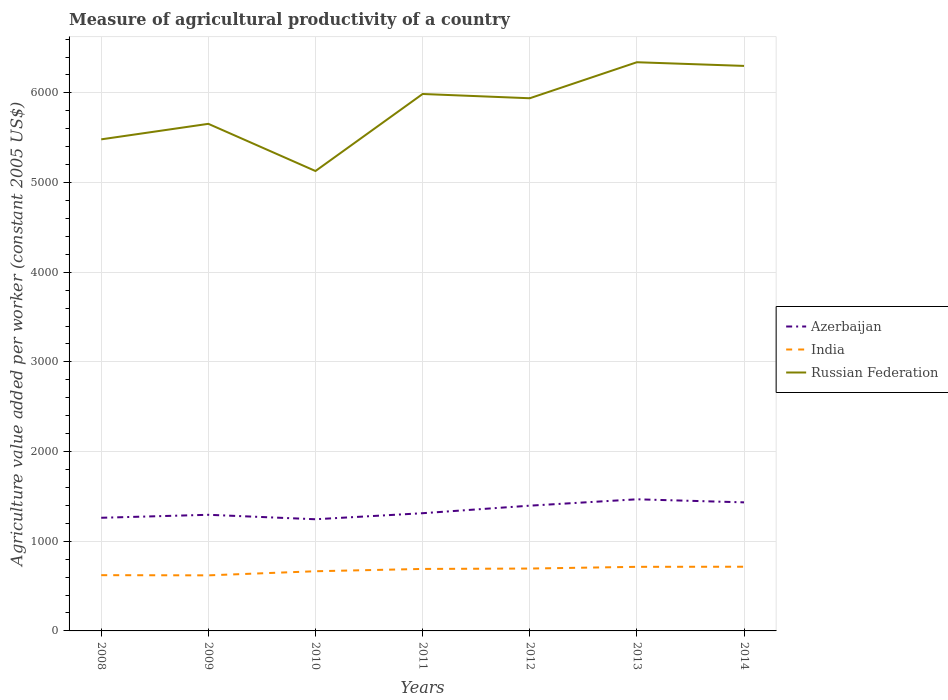Across all years, what is the maximum measure of agricultural productivity in Azerbaijan?
Make the answer very short. 1245.42. What is the total measure of agricultural productivity in Azerbaijan in the graph?
Your response must be concise. -50.89. What is the difference between the highest and the second highest measure of agricultural productivity in Azerbaijan?
Offer a very short reply. 222.61. What is the difference between the highest and the lowest measure of agricultural productivity in Russian Federation?
Ensure brevity in your answer.  4. Is the measure of agricultural productivity in Russian Federation strictly greater than the measure of agricultural productivity in Azerbaijan over the years?
Keep it short and to the point. No. How many lines are there?
Offer a very short reply. 3. How many years are there in the graph?
Give a very brief answer. 7. Are the values on the major ticks of Y-axis written in scientific E-notation?
Provide a short and direct response. No. Does the graph contain grids?
Your answer should be compact. Yes. Where does the legend appear in the graph?
Keep it short and to the point. Center right. How many legend labels are there?
Provide a succinct answer. 3. What is the title of the graph?
Your response must be concise. Measure of agricultural productivity of a country. Does "World" appear as one of the legend labels in the graph?
Provide a succinct answer. No. What is the label or title of the X-axis?
Offer a terse response. Years. What is the label or title of the Y-axis?
Provide a succinct answer. Agriculture value added per worker (constant 2005 US$). What is the Agriculture value added per worker (constant 2005 US$) in Azerbaijan in 2008?
Provide a short and direct response. 1261.92. What is the Agriculture value added per worker (constant 2005 US$) in India in 2008?
Give a very brief answer. 621.78. What is the Agriculture value added per worker (constant 2005 US$) of Russian Federation in 2008?
Offer a very short reply. 5482.32. What is the Agriculture value added per worker (constant 2005 US$) of Azerbaijan in 2009?
Provide a succinct answer. 1295.18. What is the Agriculture value added per worker (constant 2005 US$) in India in 2009?
Your response must be concise. 619.73. What is the Agriculture value added per worker (constant 2005 US$) of Russian Federation in 2009?
Make the answer very short. 5655.3. What is the Agriculture value added per worker (constant 2005 US$) in Azerbaijan in 2010?
Make the answer very short. 1245.42. What is the Agriculture value added per worker (constant 2005 US$) of India in 2010?
Offer a terse response. 665.55. What is the Agriculture value added per worker (constant 2005 US$) of Russian Federation in 2010?
Your answer should be compact. 5129.11. What is the Agriculture value added per worker (constant 2005 US$) of Azerbaijan in 2011?
Provide a succinct answer. 1312.81. What is the Agriculture value added per worker (constant 2005 US$) of India in 2011?
Provide a succinct answer. 691.34. What is the Agriculture value added per worker (constant 2005 US$) of Russian Federation in 2011?
Ensure brevity in your answer.  5988.32. What is the Agriculture value added per worker (constant 2005 US$) in Azerbaijan in 2012?
Your answer should be very brief. 1396.89. What is the Agriculture value added per worker (constant 2005 US$) of India in 2012?
Make the answer very short. 695.62. What is the Agriculture value added per worker (constant 2005 US$) in Russian Federation in 2012?
Ensure brevity in your answer.  5940.66. What is the Agriculture value added per worker (constant 2005 US$) in Azerbaijan in 2013?
Offer a very short reply. 1468.03. What is the Agriculture value added per worker (constant 2005 US$) in India in 2013?
Keep it short and to the point. 714.85. What is the Agriculture value added per worker (constant 2005 US$) in Russian Federation in 2013?
Ensure brevity in your answer.  6342.4. What is the Agriculture value added per worker (constant 2005 US$) in Azerbaijan in 2014?
Make the answer very short. 1433.81. What is the Agriculture value added per worker (constant 2005 US$) of India in 2014?
Your response must be concise. 715.89. What is the Agriculture value added per worker (constant 2005 US$) of Russian Federation in 2014?
Provide a short and direct response. 6301.37. Across all years, what is the maximum Agriculture value added per worker (constant 2005 US$) of Azerbaijan?
Make the answer very short. 1468.03. Across all years, what is the maximum Agriculture value added per worker (constant 2005 US$) of India?
Provide a succinct answer. 715.89. Across all years, what is the maximum Agriculture value added per worker (constant 2005 US$) in Russian Federation?
Offer a terse response. 6342.4. Across all years, what is the minimum Agriculture value added per worker (constant 2005 US$) in Azerbaijan?
Give a very brief answer. 1245.42. Across all years, what is the minimum Agriculture value added per worker (constant 2005 US$) in India?
Keep it short and to the point. 619.73. Across all years, what is the minimum Agriculture value added per worker (constant 2005 US$) in Russian Federation?
Ensure brevity in your answer.  5129.11. What is the total Agriculture value added per worker (constant 2005 US$) in Azerbaijan in the graph?
Offer a terse response. 9414.06. What is the total Agriculture value added per worker (constant 2005 US$) in India in the graph?
Offer a very short reply. 4724.77. What is the total Agriculture value added per worker (constant 2005 US$) in Russian Federation in the graph?
Ensure brevity in your answer.  4.08e+04. What is the difference between the Agriculture value added per worker (constant 2005 US$) in Azerbaijan in 2008 and that in 2009?
Provide a short and direct response. -33.26. What is the difference between the Agriculture value added per worker (constant 2005 US$) in India in 2008 and that in 2009?
Provide a succinct answer. 2.05. What is the difference between the Agriculture value added per worker (constant 2005 US$) in Russian Federation in 2008 and that in 2009?
Provide a short and direct response. -172.98. What is the difference between the Agriculture value added per worker (constant 2005 US$) of Azerbaijan in 2008 and that in 2010?
Your answer should be very brief. 16.5. What is the difference between the Agriculture value added per worker (constant 2005 US$) of India in 2008 and that in 2010?
Your answer should be very brief. -43.77. What is the difference between the Agriculture value added per worker (constant 2005 US$) in Russian Federation in 2008 and that in 2010?
Make the answer very short. 353.21. What is the difference between the Agriculture value added per worker (constant 2005 US$) in Azerbaijan in 2008 and that in 2011?
Ensure brevity in your answer.  -50.89. What is the difference between the Agriculture value added per worker (constant 2005 US$) in India in 2008 and that in 2011?
Give a very brief answer. -69.57. What is the difference between the Agriculture value added per worker (constant 2005 US$) in Russian Federation in 2008 and that in 2011?
Ensure brevity in your answer.  -506. What is the difference between the Agriculture value added per worker (constant 2005 US$) in Azerbaijan in 2008 and that in 2012?
Offer a very short reply. -134.97. What is the difference between the Agriculture value added per worker (constant 2005 US$) in India in 2008 and that in 2012?
Your answer should be very brief. -73.85. What is the difference between the Agriculture value added per worker (constant 2005 US$) in Russian Federation in 2008 and that in 2012?
Ensure brevity in your answer.  -458.34. What is the difference between the Agriculture value added per worker (constant 2005 US$) in Azerbaijan in 2008 and that in 2013?
Keep it short and to the point. -206.11. What is the difference between the Agriculture value added per worker (constant 2005 US$) of India in 2008 and that in 2013?
Ensure brevity in your answer.  -93.08. What is the difference between the Agriculture value added per worker (constant 2005 US$) of Russian Federation in 2008 and that in 2013?
Ensure brevity in your answer.  -860.08. What is the difference between the Agriculture value added per worker (constant 2005 US$) in Azerbaijan in 2008 and that in 2014?
Your answer should be compact. -171.89. What is the difference between the Agriculture value added per worker (constant 2005 US$) in India in 2008 and that in 2014?
Make the answer very short. -94.12. What is the difference between the Agriculture value added per worker (constant 2005 US$) of Russian Federation in 2008 and that in 2014?
Offer a very short reply. -819.05. What is the difference between the Agriculture value added per worker (constant 2005 US$) in Azerbaijan in 2009 and that in 2010?
Your response must be concise. 49.77. What is the difference between the Agriculture value added per worker (constant 2005 US$) of India in 2009 and that in 2010?
Keep it short and to the point. -45.82. What is the difference between the Agriculture value added per worker (constant 2005 US$) of Russian Federation in 2009 and that in 2010?
Provide a succinct answer. 526.19. What is the difference between the Agriculture value added per worker (constant 2005 US$) in Azerbaijan in 2009 and that in 2011?
Keep it short and to the point. -17.63. What is the difference between the Agriculture value added per worker (constant 2005 US$) of India in 2009 and that in 2011?
Keep it short and to the point. -71.62. What is the difference between the Agriculture value added per worker (constant 2005 US$) in Russian Federation in 2009 and that in 2011?
Keep it short and to the point. -333.01. What is the difference between the Agriculture value added per worker (constant 2005 US$) in Azerbaijan in 2009 and that in 2012?
Provide a succinct answer. -101.71. What is the difference between the Agriculture value added per worker (constant 2005 US$) of India in 2009 and that in 2012?
Provide a succinct answer. -75.9. What is the difference between the Agriculture value added per worker (constant 2005 US$) in Russian Federation in 2009 and that in 2012?
Keep it short and to the point. -285.35. What is the difference between the Agriculture value added per worker (constant 2005 US$) of Azerbaijan in 2009 and that in 2013?
Offer a terse response. -172.85. What is the difference between the Agriculture value added per worker (constant 2005 US$) in India in 2009 and that in 2013?
Keep it short and to the point. -95.12. What is the difference between the Agriculture value added per worker (constant 2005 US$) in Russian Federation in 2009 and that in 2013?
Offer a very short reply. -687.09. What is the difference between the Agriculture value added per worker (constant 2005 US$) of Azerbaijan in 2009 and that in 2014?
Ensure brevity in your answer.  -138.63. What is the difference between the Agriculture value added per worker (constant 2005 US$) in India in 2009 and that in 2014?
Your answer should be very brief. -96.16. What is the difference between the Agriculture value added per worker (constant 2005 US$) in Russian Federation in 2009 and that in 2014?
Your answer should be very brief. -646.07. What is the difference between the Agriculture value added per worker (constant 2005 US$) in Azerbaijan in 2010 and that in 2011?
Make the answer very short. -67.39. What is the difference between the Agriculture value added per worker (constant 2005 US$) in India in 2010 and that in 2011?
Make the answer very short. -25.79. What is the difference between the Agriculture value added per worker (constant 2005 US$) in Russian Federation in 2010 and that in 2011?
Your answer should be compact. -859.21. What is the difference between the Agriculture value added per worker (constant 2005 US$) in Azerbaijan in 2010 and that in 2012?
Your answer should be very brief. -151.47. What is the difference between the Agriculture value added per worker (constant 2005 US$) of India in 2010 and that in 2012?
Your answer should be compact. -30.07. What is the difference between the Agriculture value added per worker (constant 2005 US$) in Russian Federation in 2010 and that in 2012?
Your response must be concise. -811.55. What is the difference between the Agriculture value added per worker (constant 2005 US$) in Azerbaijan in 2010 and that in 2013?
Provide a short and direct response. -222.61. What is the difference between the Agriculture value added per worker (constant 2005 US$) in India in 2010 and that in 2013?
Provide a succinct answer. -49.3. What is the difference between the Agriculture value added per worker (constant 2005 US$) in Russian Federation in 2010 and that in 2013?
Provide a short and direct response. -1213.29. What is the difference between the Agriculture value added per worker (constant 2005 US$) in Azerbaijan in 2010 and that in 2014?
Your response must be concise. -188.39. What is the difference between the Agriculture value added per worker (constant 2005 US$) in India in 2010 and that in 2014?
Provide a short and direct response. -50.34. What is the difference between the Agriculture value added per worker (constant 2005 US$) of Russian Federation in 2010 and that in 2014?
Offer a very short reply. -1172.26. What is the difference between the Agriculture value added per worker (constant 2005 US$) in Azerbaijan in 2011 and that in 2012?
Make the answer very short. -84.08. What is the difference between the Agriculture value added per worker (constant 2005 US$) in India in 2011 and that in 2012?
Offer a terse response. -4.28. What is the difference between the Agriculture value added per worker (constant 2005 US$) of Russian Federation in 2011 and that in 2012?
Your answer should be compact. 47.66. What is the difference between the Agriculture value added per worker (constant 2005 US$) in Azerbaijan in 2011 and that in 2013?
Offer a terse response. -155.22. What is the difference between the Agriculture value added per worker (constant 2005 US$) of India in 2011 and that in 2013?
Your answer should be compact. -23.51. What is the difference between the Agriculture value added per worker (constant 2005 US$) in Russian Federation in 2011 and that in 2013?
Offer a terse response. -354.08. What is the difference between the Agriculture value added per worker (constant 2005 US$) in Azerbaijan in 2011 and that in 2014?
Your answer should be compact. -121. What is the difference between the Agriculture value added per worker (constant 2005 US$) in India in 2011 and that in 2014?
Provide a succinct answer. -24.55. What is the difference between the Agriculture value added per worker (constant 2005 US$) of Russian Federation in 2011 and that in 2014?
Provide a succinct answer. -313.05. What is the difference between the Agriculture value added per worker (constant 2005 US$) of Azerbaijan in 2012 and that in 2013?
Provide a short and direct response. -71.14. What is the difference between the Agriculture value added per worker (constant 2005 US$) in India in 2012 and that in 2013?
Your answer should be very brief. -19.23. What is the difference between the Agriculture value added per worker (constant 2005 US$) in Russian Federation in 2012 and that in 2013?
Give a very brief answer. -401.74. What is the difference between the Agriculture value added per worker (constant 2005 US$) of Azerbaijan in 2012 and that in 2014?
Offer a terse response. -36.92. What is the difference between the Agriculture value added per worker (constant 2005 US$) of India in 2012 and that in 2014?
Offer a terse response. -20.27. What is the difference between the Agriculture value added per worker (constant 2005 US$) of Russian Federation in 2012 and that in 2014?
Give a very brief answer. -360.71. What is the difference between the Agriculture value added per worker (constant 2005 US$) of Azerbaijan in 2013 and that in 2014?
Ensure brevity in your answer.  34.22. What is the difference between the Agriculture value added per worker (constant 2005 US$) of India in 2013 and that in 2014?
Offer a terse response. -1.04. What is the difference between the Agriculture value added per worker (constant 2005 US$) in Russian Federation in 2013 and that in 2014?
Provide a succinct answer. 41.03. What is the difference between the Agriculture value added per worker (constant 2005 US$) in Azerbaijan in 2008 and the Agriculture value added per worker (constant 2005 US$) in India in 2009?
Provide a short and direct response. 642.19. What is the difference between the Agriculture value added per worker (constant 2005 US$) of Azerbaijan in 2008 and the Agriculture value added per worker (constant 2005 US$) of Russian Federation in 2009?
Your response must be concise. -4393.38. What is the difference between the Agriculture value added per worker (constant 2005 US$) in India in 2008 and the Agriculture value added per worker (constant 2005 US$) in Russian Federation in 2009?
Your answer should be very brief. -5033.53. What is the difference between the Agriculture value added per worker (constant 2005 US$) in Azerbaijan in 2008 and the Agriculture value added per worker (constant 2005 US$) in India in 2010?
Give a very brief answer. 596.37. What is the difference between the Agriculture value added per worker (constant 2005 US$) of Azerbaijan in 2008 and the Agriculture value added per worker (constant 2005 US$) of Russian Federation in 2010?
Offer a terse response. -3867.19. What is the difference between the Agriculture value added per worker (constant 2005 US$) in India in 2008 and the Agriculture value added per worker (constant 2005 US$) in Russian Federation in 2010?
Keep it short and to the point. -4507.33. What is the difference between the Agriculture value added per worker (constant 2005 US$) in Azerbaijan in 2008 and the Agriculture value added per worker (constant 2005 US$) in India in 2011?
Your response must be concise. 570.58. What is the difference between the Agriculture value added per worker (constant 2005 US$) of Azerbaijan in 2008 and the Agriculture value added per worker (constant 2005 US$) of Russian Federation in 2011?
Keep it short and to the point. -4726.4. What is the difference between the Agriculture value added per worker (constant 2005 US$) of India in 2008 and the Agriculture value added per worker (constant 2005 US$) of Russian Federation in 2011?
Your response must be concise. -5366.54. What is the difference between the Agriculture value added per worker (constant 2005 US$) in Azerbaijan in 2008 and the Agriculture value added per worker (constant 2005 US$) in India in 2012?
Provide a succinct answer. 566.3. What is the difference between the Agriculture value added per worker (constant 2005 US$) of Azerbaijan in 2008 and the Agriculture value added per worker (constant 2005 US$) of Russian Federation in 2012?
Give a very brief answer. -4678.74. What is the difference between the Agriculture value added per worker (constant 2005 US$) of India in 2008 and the Agriculture value added per worker (constant 2005 US$) of Russian Federation in 2012?
Offer a terse response. -5318.88. What is the difference between the Agriculture value added per worker (constant 2005 US$) in Azerbaijan in 2008 and the Agriculture value added per worker (constant 2005 US$) in India in 2013?
Your answer should be compact. 547.07. What is the difference between the Agriculture value added per worker (constant 2005 US$) in Azerbaijan in 2008 and the Agriculture value added per worker (constant 2005 US$) in Russian Federation in 2013?
Provide a succinct answer. -5080.48. What is the difference between the Agriculture value added per worker (constant 2005 US$) of India in 2008 and the Agriculture value added per worker (constant 2005 US$) of Russian Federation in 2013?
Your response must be concise. -5720.62. What is the difference between the Agriculture value added per worker (constant 2005 US$) in Azerbaijan in 2008 and the Agriculture value added per worker (constant 2005 US$) in India in 2014?
Ensure brevity in your answer.  546.03. What is the difference between the Agriculture value added per worker (constant 2005 US$) of Azerbaijan in 2008 and the Agriculture value added per worker (constant 2005 US$) of Russian Federation in 2014?
Your answer should be very brief. -5039.45. What is the difference between the Agriculture value added per worker (constant 2005 US$) in India in 2008 and the Agriculture value added per worker (constant 2005 US$) in Russian Federation in 2014?
Ensure brevity in your answer.  -5679.59. What is the difference between the Agriculture value added per worker (constant 2005 US$) of Azerbaijan in 2009 and the Agriculture value added per worker (constant 2005 US$) of India in 2010?
Offer a very short reply. 629.63. What is the difference between the Agriculture value added per worker (constant 2005 US$) in Azerbaijan in 2009 and the Agriculture value added per worker (constant 2005 US$) in Russian Federation in 2010?
Offer a terse response. -3833.93. What is the difference between the Agriculture value added per worker (constant 2005 US$) in India in 2009 and the Agriculture value added per worker (constant 2005 US$) in Russian Federation in 2010?
Provide a short and direct response. -4509.38. What is the difference between the Agriculture value added per worker (constant 2005 US$) in Azerbaijan in 2009 and the Agriculture value added per worker (constant 2005 US$) in India in 2011?
Offer a very short reply. 603.84. What is the difference between the Agriculture value added per worker (constant 2005 US$) in Azerbaijan in 2009 and the Agriculture value added per worker (constant 2005 US$) in Russian Federation in 2011?
Provide a succinct answer. -4693.13. What is the difference between the Agriculture value added per worker (constant 2005 US$) in India in 2009 and the Agriculture value added per worker (constant 2005 US$) in Russian Federation in 2011?
Your response must be concise. -5368.59. What is the difference between the Agriculture value added per worker (constant 2005 US$) in Azerbaijan in 2009 and the Agriculture value added per worker (constant 2005 US$) in India in 2012?
Keep it short and to the point. 599.56. What is the difference between the Agriculture value added per worker (constant 2005 US$) of Azerbaijan in 2009 and the Agriculture value added per worker (constant 2005 US$) of Russian Federation in 2012?
Give a very brief answer. -4645.48. What is the difference between the Agriculture value added per worker (constant 2005 US$) in India in 2009 and the Agriculture value added per worker (constant 2005 US$) in Russian Federation in 2012?
Your response must be concise. -5320.93. What is the difference between the Agriculture value added per worker (constant 2005 US$) in Azerbaijan in 2009 and the Agriculture value added per worker (constant 2005 US$) in India in 2013?
Offer a terse response. 580.33. What is the difference between the Agriculture value added per worker (constant 2005 US$) of Azerbaijan in 2009 and the Agriculture value added per worker (constant 2005 US$) of Russian Federation in 2013?
Your answer should be very brief. -5047.21. What is the difference between the Agriculture value added per worker (constant 2005 US$) in India in 2009 and the Agriculture value added per worker (constant 2005 US$) in Russian Federation in 2013?
Your answer should be very brief. -5722.67. What is the difference between the Agriculture value added per worker (constant 2005 US$) in Azerbaijan in 2009 and the Agriculture value added per worker (constant 2005 US$) in India in 2014?
Keep it short and to the point. 579.29. What is the difference between the Agriculture value added per worker (constant 2005 US$) of Azerbaijan in 2009 and the Agriculture value added per worker (constant 2005 US$) of Russian Federation in 2014?
Provide a succinct answer. -5006.19. What is the difference between the Agriculture value added per worker (constant 2005 US$) in India in 2009 and the Agriculture value added per worker (constant 2005 US$) in Russian Federation in 2014?
Provide a succinct answer. -5681.64. What is the difference between the Agriculture value added per worker (constant 2005 US$) of Azerbaijan in 2010 and the Agriculture value added per worker (constant 2005 US$) of India in 2011?
Your answer should be very brief. 554.07. What is the difference between the Agriculture value added per worker (constant 2005 US$) in Azerbaijan in 2010 and the Agriculture value added per worker (constant 2005 US$) in Russian Federation in 2011?
Give a very brief answer. -4742.9. What is the difference between the Agriculture value added per worker (constant 2005 US$) of India in 2010 and the Agriculture value added per worker (constant 2005 US$) of Russian Federation in 2011?
Your response must be concise. -5322.77. What is the difference between the Agriculture value added per worker (constant 2005 US$) in Azerbaijan in 2010 and the Agriculture value added per worker (constant 2005 US$) in India in 2012?
Keep it short and to the point. 549.79. What is the difference between the Agriculture value added per worker (constant 2005 US$) of Azerbaijan in 2010 and the Agriculture value added per worker (constant 2005 US$) of Russian Federation in 2012?
Your answer should be compact. -4695.24. What is the difference between the Agriculture value added per worker (constant 2005 US$) in India in 2010 and the Agriculture value added per worker (constant 2005 US$) in Russian Federation in 2012?
Offer a very short reply. -5275.11. What is the difference between the Agriculture value added per worker (constant 2005 US$) of Azerbaijan in 2010 and the Agriculture value added per worker (constant 2005 US$) of India in 2013?
Make the answer very short. 530.56. What is the difference between the Agriculture value added per worker (constant 2005 US$) of Azerbaijan in 2010 and the Agriculture value added per worker (constant 2005 US$) of Russian Federation in 2013?
Provide a succinct answer. -5096.98. What is the difference between the Agriculture value added per worker (constant 2005 US$) of India in 2010 and the Agriculture value added per worker (constant 2005 US$) of Russian Federation in 2013?
Make the answer very short. -5676.85. What is the difference between the Agriculture value added per worker (constant 2005 US$) in Azerbaijan in 2010 and the Agriculture value added per worker (constant 2005 US$) in India in 2014?
Offer a very short reply. 529.52. What is the difference between the Agriculture value added per worker (constant 2005 US$) in Azerbaijan in 2010 and the Agriculture value added per worker (constant 2005 US$) in Russian Federation in 2014?
Make the answer very short. -5055.95. What is the difference between the Agriculture value added per worker (constant 2005 US$) of India in 2010 and the Agriculture value added per worker (constant 2005 US$) of Russian Federation in 2014?
Provide a succinct answer. -5635.82. What is the difference between the Agriculture value added per worker (constant 2005 US$) of Azerbaijan in 2011 and the Agriculture value added per worker (constant 2005 US$) of India in 2012?
Give a very brief answer. 617.19. What is the difference between the Agriculture value added per worker (constant 2005 US$) of Azerbaijan in 2011 and the Agriculture value added per worker (constant 2005 US$) of Russian Federation in 2012?
Offer a very short reply. -4627.85. What is the difference between the Agriculture value added per worker (constant 2005 US$) of India in 2011 and the Agriculture value added per worker (constant 2005 US$) of Russian Federation in 2012?
Offer a very short reply. -5249.31. What is the difference between the Agriculture value added per worker (constant 2005 US$) of Azerbaijan in 2011 and the Agriculture value added per worker (constant 2005 US$) of India in 2013?
Your answer should be compact. 597.96. What is the difference between the Agriculture value added per worker (constant 2005 US$) of Azerbaijan in 2011 and the Agriculture value added per worker (constant 2005 US$) of Russian Federation in 2013?
Provide a succinct answer. -5029.59. What is the difference between the Agriculture value added per worker (constant 2005 US$) of India in 2011 and the Agriculture value added per worker (constant 2005 US$) of Russian Federation in 2013?
Offer a terse response. -5651.05. What is the difference between the Agriculture value added per worker (constant 2005 US$) of Azerbaijan in 2011 and the Agriculture value added per worker (constant 2005 US$) of India in 2014?
Keep it short and to the point. 596.92. What is the difference between the Agriculture value added per worker (constant 2005 US$) of Azerbaijan in 2011 and the Agriculture value added per worker (constant 2005 US$) of Russian Federation in 2014?
Keep it short and to the point. -4988.56. What is the difference between the Agriculture value added per worker (constant 2005 US$) of India in 2011 and the Agriculture value added per worker (constant 2005 US$) of Russian Federation in 2014?
Ensure brevity in your answer.  -5610.03. What is the difference between the Agriculture value added per worker (constant 2005 US$) in Azerbaijan in 2012 and the Agriculture value added per worker (constant 2005 US$) in India in 2013?
Give a very brief answer. 682.04. What is the difference between the Agriculture value added per worker (constant 2005 US$) of Azerbaijan in 2012 and the Agriculture value added per worker (constant 2005 US$) of Russian Federation in 2013?
Your response must be concise. -4945.51. What is the difference between the Agriculture value added per worker (constant 2005 US$) of India in 2012 and the Agriculture value added per worker (constant 2005 US$) of Russian Federation in 2013?
Your answer should be compact. -5646.77. What is the difference between the Agriculture value added per worker (constant 2005 US$) in Azerbaijan in 2012 and the Agriculture value added per worker (constant 2005 US$) in India in 2014?
Offer a very short reply. 681. What is the difference between the Agriculture value added per worker (constant 2005 US$) of Azerbaijan in 2012 and the Agriculture value added per worker (constant 2005 US$) of Russian Federation in 2014?
Your answer should be very brief. -4904.48. What is the difference between the Agriculture value added per worker (constant 2005 US$) of India in 2012 and the Agriculture value added per worker (constant 2005 US$) of Russian Federation in 2014?
Your answer should be very brief. -5605.75. What is the difference between the Agriculture value added per worker (constant 2005 US$) in Azerbaijan in 2013 and the Agriculture value added per worker (constant 2005 US$) in India in 2014?
Your response must be concise. 752.14. What is the difference between the Agriculture value added per worker (constant 2005 US$) in Azerbaijan in 2013 and the Agriculture value added per worker (constant 2005 US$) in Russian Federation in 2014?
Your answer should be very brief. -4833.34. What is the difference between the Agriculture value added per worker (constant 2005 US$) in India in 2013 and the Agriculture value added per worker (constant 2005 US$) in Russian Federation in 2014?
Your response must be concise. -5586.52. What is the average Agriculture value added per worker (constant 2005 US$) of Azerbaijan per year?
Provide a short and direct response. 1344.87. What is the average Agriculture value added per worker (constant 2005 US$) of India per year?
Provide a succinct answer. 674.97. What is the average Agriculture value added per worker (constant 2005 US$) in Russian Federation per year?
Offer a terse response. 5834.21. In the year 2008, what is the difference between the Agriculture value added per worker (constant 2005 US$) of Azerbaijan and Agriculture value added per worker (constant 2005 US$) of India?
Ensure brevity in your answer.  640.14. In the year 2008, what is the difference between the Agriculture value added per worker (constant 2005 US$) of Azerbaijan and Agriculture value added per worker (constant 2005 US$) of Russian Federation?
Your answer should be compact. -4220.4. In the year 2008, what is the difference between the Agriculture value added per worker (constant 2005 US$) of India and Agriculture value added per worker (constant 2005 US$) of Russian Federation?
Provide a succinct answer. -4860.54. In the year 2009, what is the difference between the Agriculture value added per worker (constant 2005 US$) in Azerbaijan and Agriculture value added per worker (constant 2005 US$) in India?
Your response must be concise. 675.46. In the year 2009, what is the difference between the Agriculture value added per worker (constant 2005 US$) of Azerbaijan and Agriculture value added per worker (constant 2005 US$) of Russian Federation?
Provide a succinct answer. -4360.12. In the year 2009, what is the difference between the Agriculture value added per worker (constant 2005 US$) of India and Agriculture value added per worker (constant 2005 US$) of Russian Federation?
Keep it short and to the point. -5035.58. In the year 2010, what is the difference between the Agriculture value added per worker (constant 2005 US$) of Azerbaijan and Agriculture value added per worker (constant 2005 US$) of India?
Offer a terse response. 579.87. In the year 2010, what is the difference between the Agriculture value added per worker (constant 2005 US$) of Azerbaijan and Agriculture value added per worker (constant 2005 US$) of Russian Federation?
Your response must be concise. -3883.69. In the year 2010, what is the difference between the Agriculture value added per worker (constant 2005 US$) of India and Agriculture value added per worker (constant 2005 US$) of Russian Federation?
Offer a terse response. -4463.56. In the year 2011, what is the difference between the Agriculture value added per worker (constant 2005 US$) in Azerbaijan and Agriculture value added per worker (constant 2005 US$) in India?
Your answer should be very brief. 621.47. In the year 2011, what is the difference between the Agriculture value added per worker (constant 2005 US$) of Azerbaijan and Agriculture value added per worker (constant 2005 US$) of Russian Federation?
Your answer should be very brief. -4675.51. In the year 2011, what is the difference between the Agriculture value added per worker (constant 2005 US$) of India and Agriculture value added per worker (constant 2005 US$) of Russian Federation?
Keep it short and to the point. -5296.97. In the year 2012, what is the difference between the Agriculture value added per worker (constant 2005 US$) of Azerbaijan and Agriculture value added per worker (constant 2005 US$) of India?
Keep it short and to the point. 701.27. In the year 2012, what is the difference between the Agriculture value added per worker (constant 2005 US$) in Azerbaijan and Agriculture value added per worker (constant 2005 US$) in Russian Federation?
Offer a terse response. -4543.77. In the year 2012, what is the difference between the Agriculture value added per worker (constant 2005 US$) of India and Agriculture value added per worker (constant 2005 US$) of Russian Federation?
Offer a terse response. -5245.03. In the year 2013, what is the difference between the Agriculture value added per worker (constant 2005 US$) in Azerbaijan and Agriculture value added per worker (constant 2005 US$) in India?
Keep it short and to the point. 753.18. In the year 2013, what is the difference between the Agriculture value added per worker (constant 2005 US$) of Azerbaijan and Agriculture value added per worker (constant 2005 US$) of Russian Federation?
Keep it short and to the point. -4874.37. In the year 2013, what is the difference between the Agriculture value added per worker (constant 2005 US$) of India and Agriculture value added per worker (constant 2005 US$) of Russian Federation?
Your answer should be compact. -5627.55. In the year 2014, what is the difference between the Agriculture value added per worker (constant 2005 US$) of Azerbaijan and Agriculture value added per worker (constant 2005 US$) of India?
Your answer should be compact. 717.92. In the year 2014, what is the difference between the Agriculture value added per worker (constant 2005 US$) in Azerbaijan and Agriculture value added per worker (constant 2005 US$) in Russian Federation?
Your answer should be very brief. -4867.56. In the year 2014, what is the difference between the Agriculture value added per worker (constant 2005 US$) of India and Agriculture value added per worker (constant 2005 US$) of Russian Federation?
Offer a terse response. -5585.48. What is the ratio of the Agriculture value added per worker (constant 2005 US$) of Azerbaijan in 2008 to that in 2009?
Make the answer very short. 0.97. What is the ratio of the Agriculture value added per worker (constant 2005 US$) in India in 2008 to that in 2009?
Give a very brief answer. 1. What is the ratio of the Agriculture value added per worker (constant 2005 US$) of Russian Federation in 2008 to that in 2009?
Your response must be concise. 0.97. What is the ratio of the Agriculture value added per worker (constant 2005 US$) in Azerbaijan in 2008 to that in 2010?
Offer a very short reply. 1.01. What is the ratio of the Agriculture value added per worker (constant 2005 US$) of India in 2008 to that in 2010?
Give a very brief answer. 0.93. What is the ratio of the Agriculture value added per worker (constant 2005 US$) in Russian Federation in 2008 to that in 2010?
Ensure brevity in your answer.  1.07. What is the ratio of the Agriculture value added per worker (constant 2005 US$) in Azerbaijan in 2008 to that in 2011?
Provide a short and direct response. 0.96. What is the ratio of the Agriculture value added per worker (constant 2005 US$) of India in 2008 to that in 2011?
Offer a very short reply. 0.9. What is the ratio of the Agriculture value added per worker (constant 2005 US$) in Russian Federation in 2008 to that in 2011?
Ensure brevity in your answer.  0.92. What is the ratio of the Agriculture value added per worker (constant 2005 US$) in Azerbaijan in 2008 to that in 2012?
Provide a succinct answer. 0.9. What is the ratio of the Agriculture value added per worker (constant 2005 US$) in India in 2008 to that in 2012?
Provide a short and direct response. 0.89. What is the ratio of the Agriculture value added per worker (constant 2005 US$) of Russian Federation in 2008 to that in 2012?
Keep it short and to the point. 0.92. What is the ratio of the Agriculture value added per worker (constant 2005 US$) of Azerbaijan in 2008 to that in 2013?
Make the answer very short. 0.86. What is the ratio of the Agriculture value added per worker (constant 2005 US$) in India in 2008 to that in 2013?
Offer a very short reply. 0.87. What is the ratio of the Agriculture value added per worker (constant 2005 US$) in Russian Federation in 2008 to that in 2013?
Make the answer very short. 0.86. What is the ratio of the Agriculture value added per worker (constant 2005 US$) in Azerbaijan in 2008 to that in 2014?
Keep it short and to the point. 0.88. What is the ratio of the Agriculture value added per worker (constant 2005 US$) in India in 2008 to that in 2014?
Make the answer very short. 0.87. What is the ratio of the Agriculture value added per worker (constant 2005 US$) of Russian Federation in 2008 to that in 2014?
Provide a short and direct response. 0.87. What is the ratio of the Agriculture value added per worker (constant 2005 US$) in India in 2009 to that in 2010?
Provide a succinct answer. 0.93. What is the ratio of the Agriculture value added per worker (constant 2005 US$) in Russian Federation in 2009 to that in 2010?
Your answer should be compact. 1.1. What is the ratio of the Agriculture value added per worker (constant 2005 US$) in Azerbaijan in 2009 to that in 2011?
Offer a terse response. 0.99. What is the ratio of the Agriculture value added per worker (constant 2005 US$) in India in 2009 to that in 2011?
Give a very brief answer. 0.9. What is the ratio of the Agriculture value added per worker (constant 2005 US$) in Azerbaijan in 2009 to that in 2012?
Your response must be concise. 0.93. What is the ratio of the Agriculture value added per worker (constant 2005 US$) of India in 2009 to that in 2012?
Make the answer very short. 0.89. What is the ratio of the Agriculture value added per worker (constant 2005 US$) in Azerbaijan in 2009 to that in 2013?
Your answer should be compact. 0.88. What is the ratio of the Agriculture value added per worker (constant 2005 US$) of India in 2009 to that in 2013?
Ensure brevity in your answer.  0.87. What is the ratio of the Agriculture value added per worker (constant 2005 US$) of Russian Federation in 2009 to that in 2013?
Provide a short and direct response. 0.89. What is the ratio of the Agriculture value added per worker (constant 2005 US$) in Azerbaijan in 2009 to that in 2014?
Provide a succinct answer. 0.9. What is the ratio of the Agriculture value added per worker (constant 2005 US$) of India in 2009 to that in 2014?
Ensure brevity in your answer.  0.87. What is the ratio of the Agriculture value added per worker (constant 2005 US$) of Russian Federation in 2009 to that in 2014?
Ensure brevity in your answer.  0.9. What is the ratio of the Agriculture value added per worker (constant 2005 US$) of Azerbaijan in 2010 to that in 2011?
Make the answer very short. 0.95. What is the ratio of the Agriculture value added per worker (constant 2005 US$) of India in 2010 to that in 2011?
Your answer should be compact. 0.96. What is the ratio of the Agriculture value added per worker (constant 2005 US$) in Russian Federation in 2010 to that in 2011?
Your answer should be compact. 0.86. What is the ratio of the Agriculture value added per worker (constant 2005 US$) in Azerbaijan in 2010 to that in 2012?
Provide a succinct answer. 0.89. What is the ratio of the Agriculture value added per worker (constant 2005 US$) of India in 2010 to that in 2012?
Provide a succinct answer. 0.96. What is the ratio of the Agriculture value added per worker (constant 2005 US$) of Russian Federation in 2010 to that in 2012?
Provide a succinct answer. 0.86. What is the ratio of the Agriculture value added per worker (constant 2005 US$) in Azerbaijan in 2010 to that in 2013?
Ensure brevity in your answer.  0.85. What is the ratio of the Agriculture value added per worker (constant 2005 US$) in Russian Federation in 2010 to that in 2013?
Offer a terse response. 0.81. What is the ratio of the Agriculture value added per worker (constant 2005 US$) in Azerbaijan in 2010 to that in 2014?
Offer a very short reply. 0.87. What is the ratio of the Agriculture value added per worker (constant 2005 US$) in India in 2010 to that in 2014?
Offer a terse response. 0.93. What is the ratio of the Agriculture value added per worker (constant 2005 US$) of Russian Federation in 2010 to that in 2014?
Your answer should be compact. 0.81. What is the ratio of the Agriculture value added per worker (constant 2005 US$) of Azerbaijan in 2011 to that in 2012?
Offer a very short reply. 0.94. What is the ratio of the Agriculture value added per worker (constant 2005 US$) of India in 2011 to that in 2012?
Your response must be concise. 0.99. What is the ratio of the Agriculture value added per worker (constant 2005 US$) of Azerbaijan in 2011 to that in 2013?
Make the answer very short. 0.89. What is the ratio of the Agriculture value added per worker (constant 2005 US$) in India in 2011 to that in 2013?
Your answer should be very brief. 0.97. What is the ratio of the Agriculture value added per worker (constant 2005 US$) of Russian Federation in 2011 to that in 2013?
Your answer should be compact. 0.94. What is the ratio of the Agriculture value added per worker (constant 2005 US$) in Azerbaijan in 2011 to that in 2014?
Your response must be concise. 0.92. What is the ratio of the Agriculture value added per worker (constant 2005 US$) of India in 2011 to that in 2014?
Your answer should be very brief. 0.97. What is the ratio of the Agriculture value added per worker (constant 2005 US$) in Russian Federation in 2011 to that in 2014?
Give a very brief answer. 0.95. What is the ratio of the Agriculture value added per worker (constant 2005 US$) of Azerbaijan in 2012 to that in 2013?
Provide a short and direct response. 0.95. What is the ratio of the Agriculture value added per worker (constant 2005 US$) of India in 2012 to that in 2013?
Your answer should be very brief. 0.97. What is the ratio of the Agriculture value added per worker (constant 2005 US$) in Russian Federation in 2012 to that in 2013?
Ensure brevity in your answer.  0.94. What is the ratio of the Agriculture value added per worker (constant 2005 US$) of Azerbaijan in 2012 to that in 2014?
Offer a very short reply. 0.97. What is the ratio of the Agriculture value added per worker (constant 2005 US$) of India in 2012 to that in 2014?
Offer a very short reply. 0.97. What is the ratio of the Agriculture value added per worker (constant 2005 US$) of Russian Federation in 2012 to that in 2014?
Make the answer very short. 0.94. What is the ratio of the Agriculture value added per worker (constant 2005 US$) in Azerbaijan in 2013 to that in 2014?
Your answer should be very brief. 1.02. What is the ratio of the Agriculture value added per worker (constant 2005 US$) of India in 2013 to that in 2014?
Your answer should be compact. 1. What is the difference between the highest and the second highest Agriculture value added per worker (constant 2005 US$) of Azerbaijan?
Provide a short and direct response. 34.22. What is the difference between the highest and the second highest Agriculture value added per worker (constant 2005 US$) of India?
Make the answer very short. 1.04. What is the difference between the highest and the second highest Agriculture value added per worker (constant 2005 US$) in Russian Federation?
Offer a very short reply. 41.03. What is the difference between the highest and the lowest Agriculture value added per worker (constant 2005 US$) of Azerbaijan?
Make the answer very short. 222.61. What is the difference between the highest and the lowest Agriculture value added per worker (constant 2005 US$) in India?
Make the answer very short. 96.16. What is the difference between the highest and the lowest Agriculture value added per worker (constant 2005 US$) of Russian Federation?
Offer a terse response. 1213.29. 